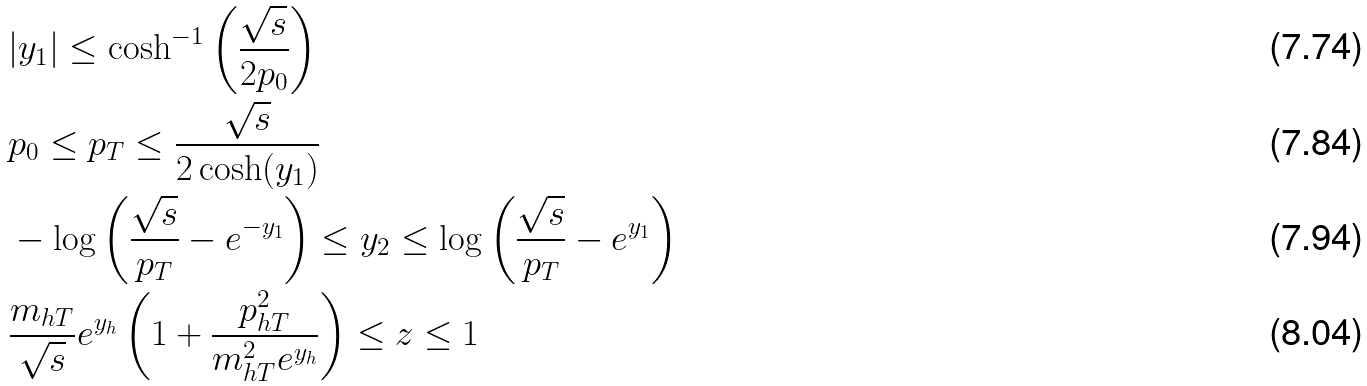Convert formula to latex. <formula><loc_0><loc_0><loc_500><loc_500>& | y _ { 1 } | \leq \cosh ^ { - 1 } \left ( \frac { \sqrt { s } } { 2 p _ { 0 } } \right ) \\ & p _ { 0 } \leq p _ { T } \leq \frac { \sqrt { s } } { 2 \cosh ( y _ { 1 } ) } \\ & - \log \left ( \frac { \sqrt { s } } { p _ { T } } - e ^ { - y _ { 1 } } \right ) \leq y _ { 2 } \leq \log \left ( \frac { \sqrt { s } } { p _ { T } } - e ^ { y _ { 1 } } \right ) \\ & \frac { m _ { h T } } { \sqrt { s } } e ^ { y _ { h } } \left ( 1 + \frac { p _ { h T } ^ { 2 } } { m _ { h T } ^ { 2 } e ^ { y _ { h } } } \right ) \leq z \leq 1</formula> 